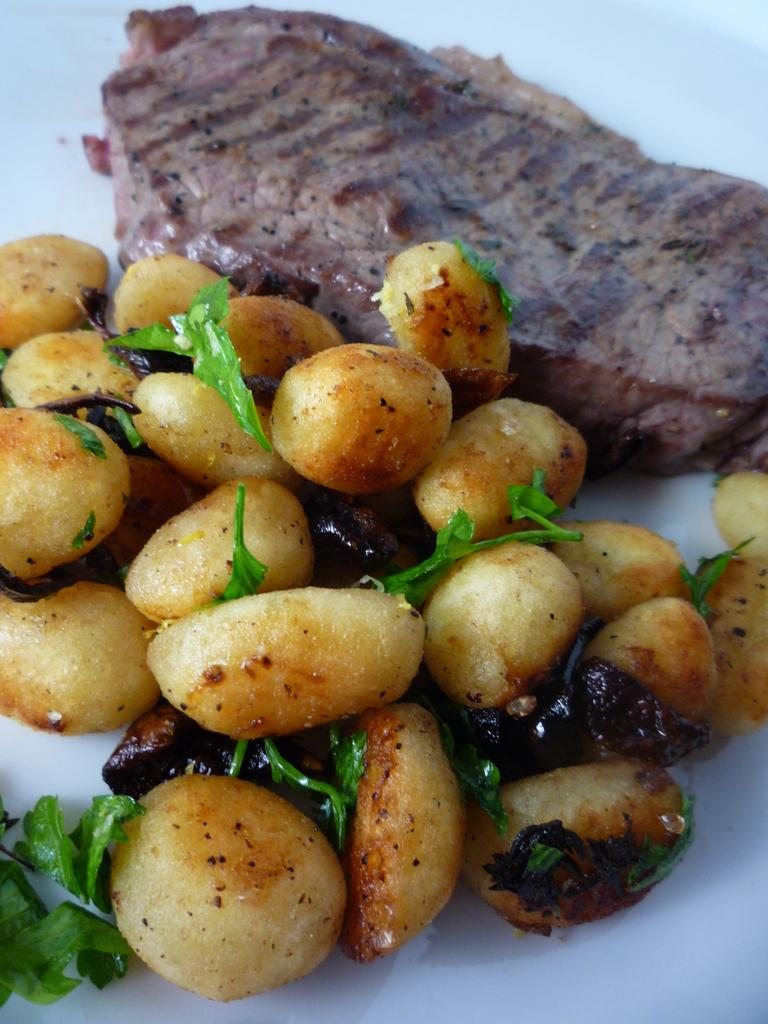What is the main subject of the image? The main subject of the image is food. Where is the food located in the image? The food is on a platform. What type of oil is being used to cook the food in the image? There is no indication of cooking or oil in the image; it only shows food on a platform. What class of people might be associated with the food in the image? There is no information about the class of people or any social context in the image. 